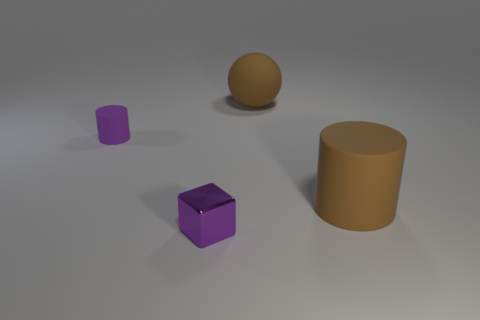There is a matte object behind the purple thing left of the tiny purple metallic cube; what is its color?
Your answer should be very brief. Brown. Are there fewer small purple metallic things left of the tiny metal cube than tiny purple cylinders that are behind the brown matte cylinder?
Your answer should be compact. Yes. What is the material of the block that is the same color as the small cylinder?
Ensure brevity in your answer.  Metal. How many objects are rubber cylinders left of the big cylinder or spheres?
Offer a terse response. 2. There is a purple object right of the purple rubber object; is it the same size as the purple matte cylinder?
Keep it short and to the point. Yes. Are there fewer rubber cylinders on the right side of the big matte cylinder than large brown matte things?
Ensure brevity in your answer.  Yes. There is a brown object that is the same size as the brown rubber cylinder; what is its material?
Your answer should be compact. Rubber. How many small objects are yellow metallic cylinders or brown objects?
Your response must be concise. 0. What number of objects are either brown rubber objects in front of the brown sphere or rubber objects that are left of the large cylinder?
Ensure brevity in your answer.  3. Is the number of metal objects less than the number of large blue shiny things?
Offer a very short reply. No. 